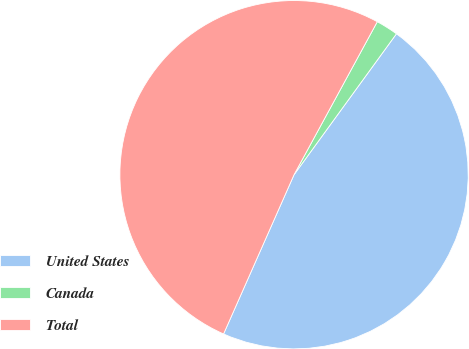<chart> <loc_0><loc_0><loc_500><loc_500><pie_chart><fcel>United States<fcel>Canada<fcel>Total<nl><fcel>46.63%<fcel>2.07%<fcel>51.3%<nl></chart> 